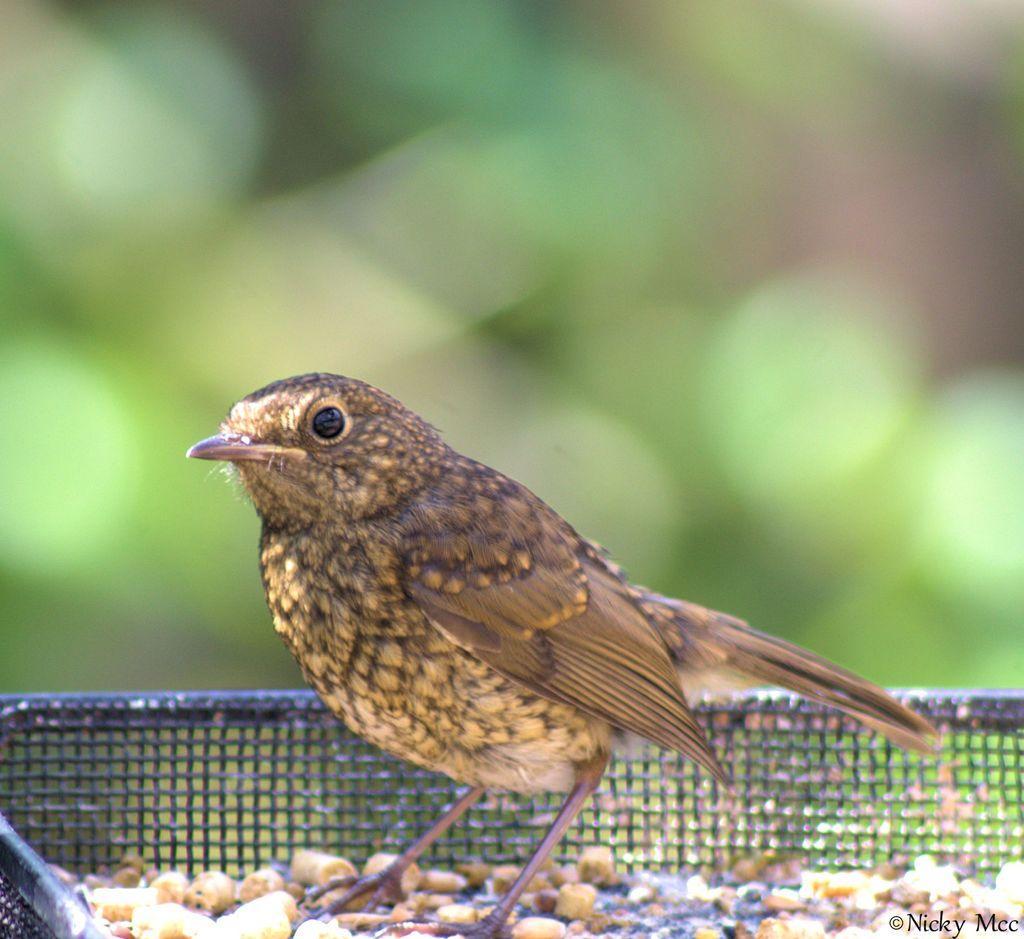In one or two sentences, can you explain what this image depicts? In this image I see a bird which is of cream and brown in color and I see the netted thing over here and I see brown color things over here and I see the watermark and it is blurred in the background. 